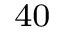Convert formula to latex. <formula><loc_0><loc_0><loc_500><loc_500>_ { 4 0 }</formula> 